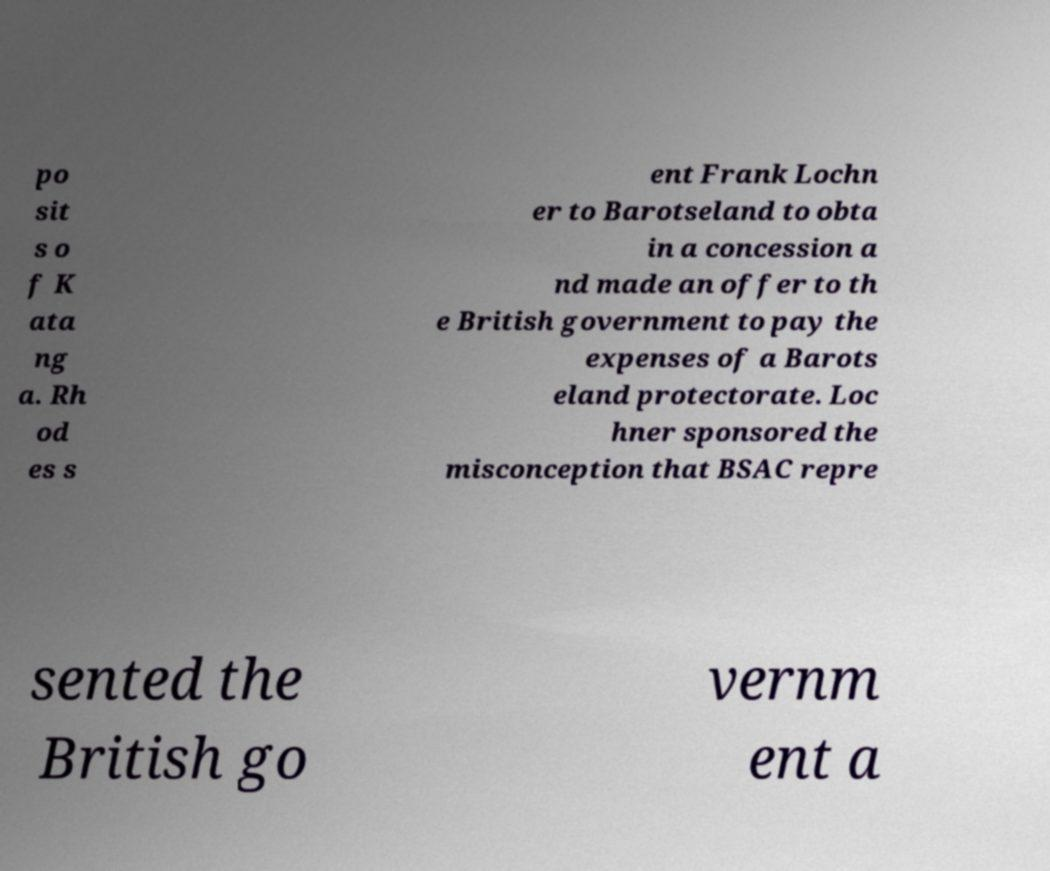What messages or text are displayed in this image? I need them in a readable, typed format. po sit s o f K ata ng a. Rh od es s ent Frank Lochn er to Barotseland to obta in a concession a nd made an offer to th e British government to pay the expenses of a Barots eland protectorate. Loc hner sponsored the misconception that BSAC repre sented the British go vernm ent a 